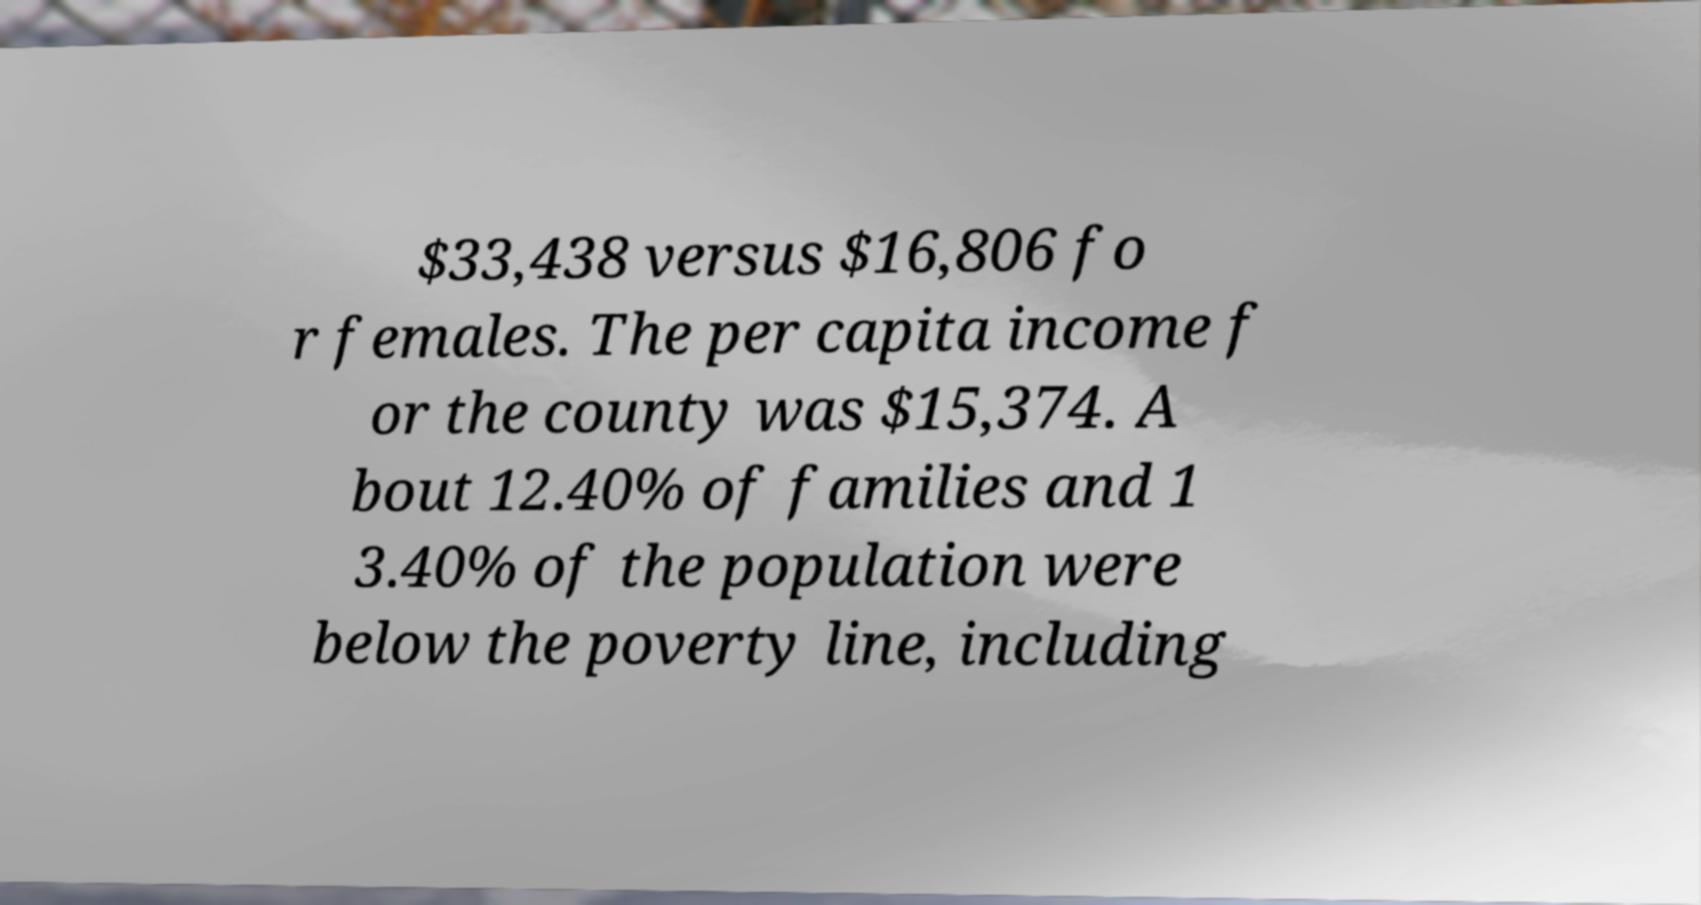Please read and relay the text visible in this image. What does it say? $33,438 versus $16,806 fo r females. The per capita income f or the county was $15,374. A bout 12.40% of families and 1 3.40% of the population were below the poverty line, including 